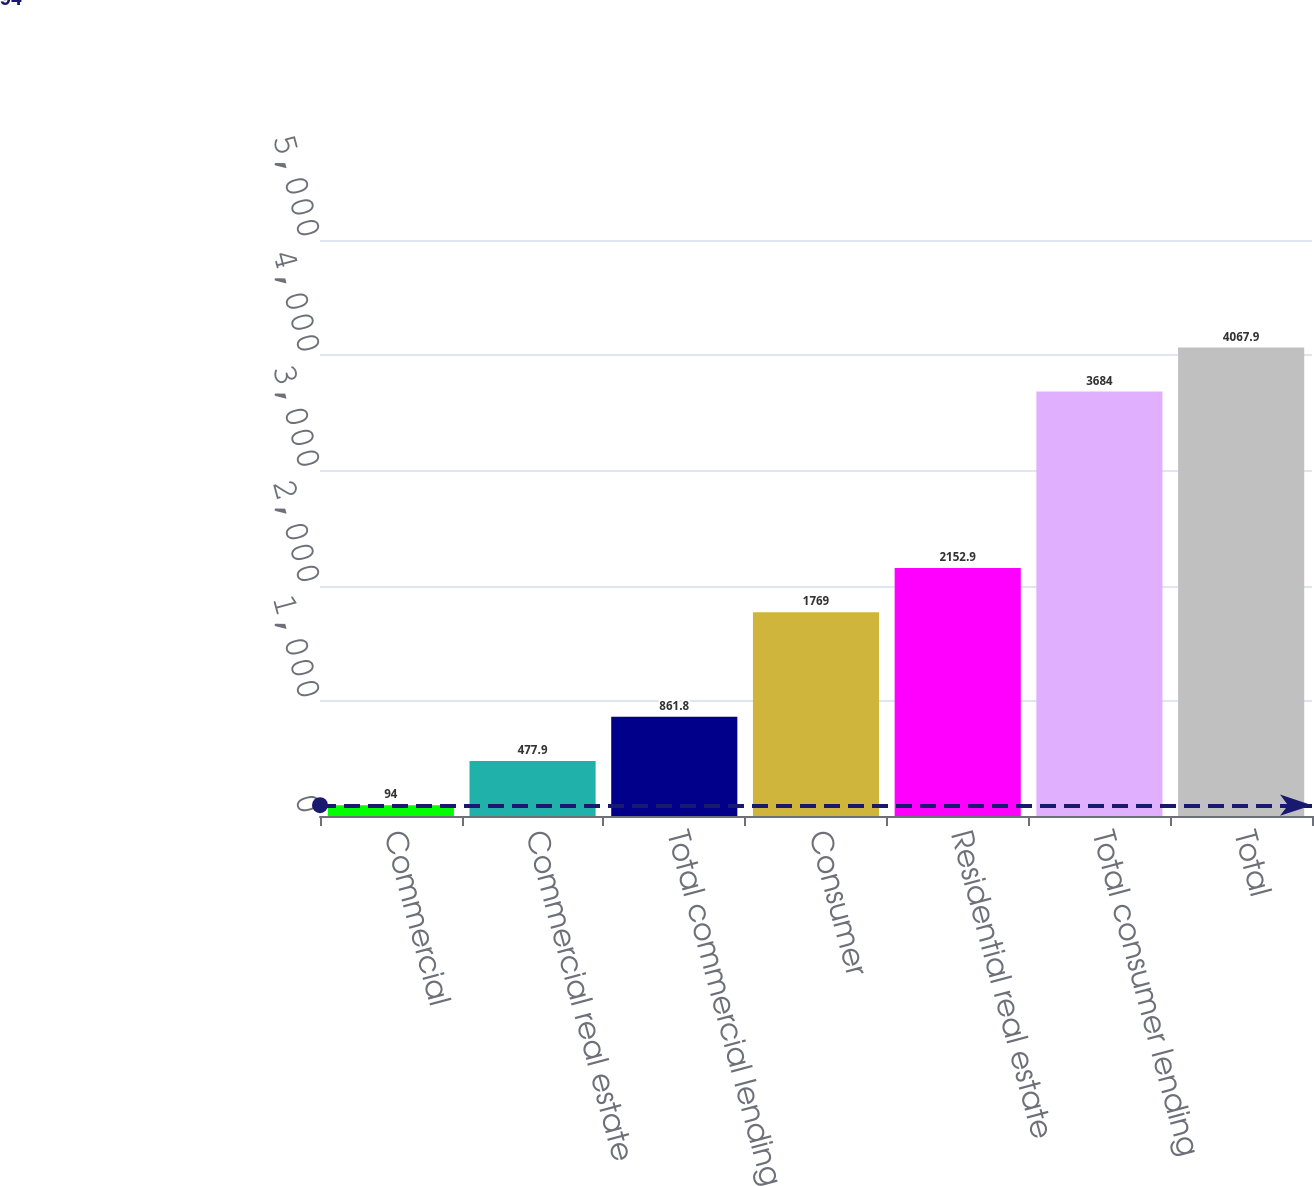Convert chart to OTSL. <chart><loc_0><loc_0><loc_500><loc_500><bar_chart><fcel>Commercial<fcel>Commercial real estate<fcel>Total commercial lending<fcel>Consumer<fcel>Residential real estate<fcel>Total consumer lending<fcel>Total<nl><fcel>94<fcel>477.9<fcel>861.8<fcel>1769<fcel>2152.9<fcel>3684<fcel>4067.9<nl></chart> 